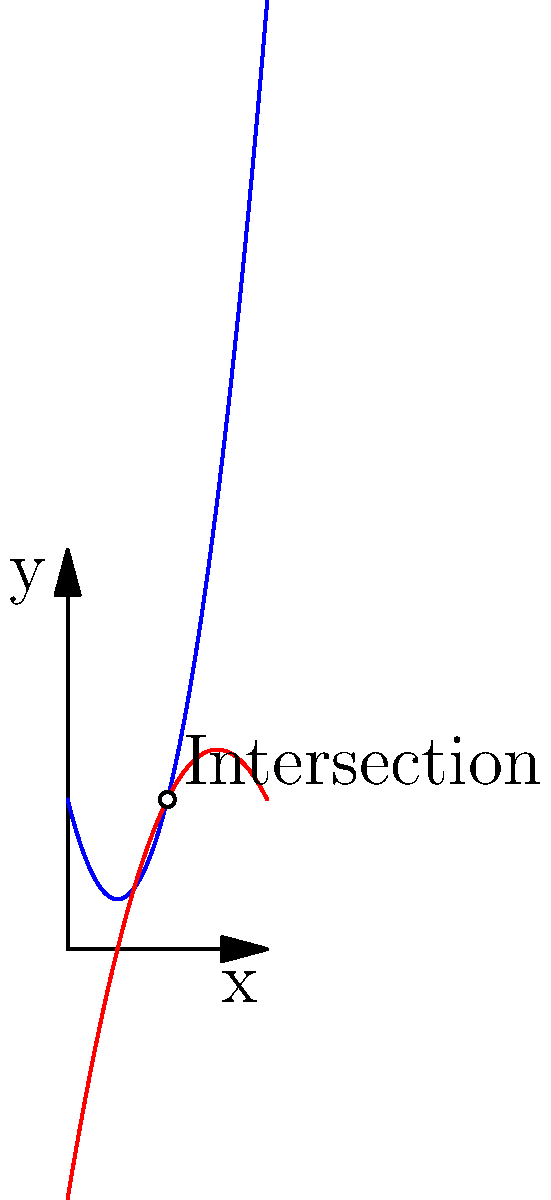In your latest screenplay, two storylines converge at a critical point. Storyline A is represented by the function $f(x) = 2x^2 - 4x + 3$, while Storyline B is represented by $g(x) = -x^2 + 6x - 5$. At what point do these storylines intersect, and what is the area between the curves from $x = 0$ to this intersection point? 1. Find the intersection point:
   Set $f(x) = g(x)$
   $2x^2 - 4x + 3 = -x^2 + 6x - 5$
   $3x^2 - 10x + 8 = 0$
   
2. Solve the quadratic equation:
   $a = 3, b = -10, c = 8$
   $x = \frac{-b \pm \sqrt{b^2 - 4ac}}{2a}$
   $x = \frac{10 \pm \sqrt{100 - 96}}{6} = \frac{10 \pm 2}{6}$
   $x = 2$ or $x = \frac{4}{3}$

3. The intersection point in our domain is $(2, 3)$

4. To find the area between the curves, we need to integrate the difference:
   $A = \int_0^2 (g(x) - f(x)) dx$
   $A = \int_0^2 ((-x^2 + 6x - 5) - (2x^2 - 4x + 3)) dx$
   $A = \int_0^2 (-3x^2 + 10x - 8) dx$

5. Integrate:
   $A = [-x^3 + 5x^2 - 8x]_0^2$
   $A = [(-8 + 20 - 16) - (0 + 0 - 0)]$
   $A = -4$

6. The absolute area is 4 square units.
Answer: Intersection point: (2, 3); Area between curves: 4 square units 